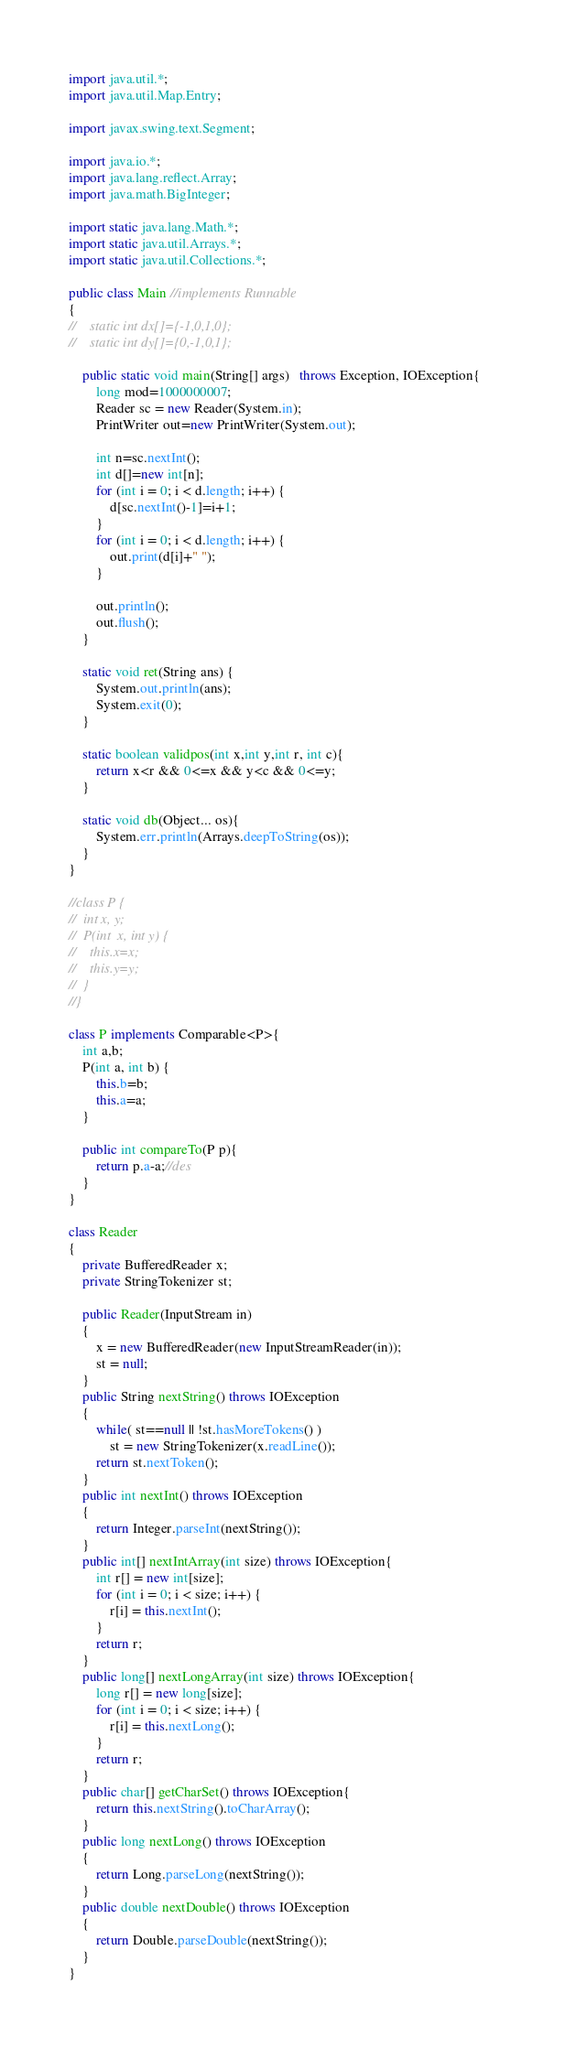Convert code to text. <code><loc_0><loc_0><loc_500><loc_500><_Java_>import java.util.*;
import java.util.Map.Entry;

import javax.swing.text.Segment;

import java.io.*;
import java.lang.reflect.Array;
import java.math.BigInteger;

import static java.lang.Math.*;
import static java.util.Arrays.*;
import static java.util.Collections.*;
 
public class Main //implements Runnable
{
//    static int dx[]={-1,0,1,0};
//    static int dy[]={0,-1,0,1};

    public static void main(String[] args)   throws Exception, IOException{        
        long mod=1000000007;
        Reader sc = new Reader(System.in);
        PrintWriter out=new PrintWriter(System.out);

        int n=sc.nextInt();
        int d[]=new int[n];
        for (int i = 0; i < d.length; i++) {
			d[sc.nextInt()-1]=i+1;
		}
        for (int i = 0; i < d.length; i++) {
			out.print(d[i]+" ");
		}
        
        out.println();
     	out.flush();
    }
    
    static void ret(String ans) {
    	System.out.println(ans);
    	System.exit(0);
    }
    
    static boolean validpos(int x,int y,int r, int c){
        return x<r && 0<=x && y<c && 0<=y;
    }

    static void db(Object... os){
        System.err.println(Arrays.deepToString(os));
    }
}

//class P {
//	int x, y;
//	P(int  x, int y) {
//	  this.x=x;
//	  this.y=y;
//	}
//}

class P implements Comparable<P>{
    int a,b;
    P(int a, int b) {
    	this.b=b;
    	this.a=a;
    }

    public int compareTo(P p){
        return p.a-a;//des
    }
}

class Reader
{ 
    private BufferedReader x;
    private StringTokenizer st;
    
    public Reader(InputStream in)
    {
        x = new BufferedReader(new InputStreamReader(in));
        st = null;
    }
    public String nextString() throws IOException
    {
        while( st==null || !st.hasMoreTokens() )
            st = new StringTokenizer(x.readLine());
        return st.nextToken();
    }
    public int nextInt() throws IOException
    {
        return Integer.parseInt(nextString());
    }
    public int[] nextIntArray(int size) throws IOException{
        int r[] = new int[size];
        for (int i = 0; i < size; i++) {
            r[i] = this.nextInt(); 
        }
        return r;
    }
    public long[] nextLongArray(int size) throws IOException{
        long r[] = new long[size];
        for (int i = 0; i < size; i++) {
            r[i] = this.nextLong(); 
        }
        return r;
    }
    public char[] getCharSet() throws IOException{
        return this.nextString().toCharArray();
    }    
    public long nextLong() throws IOException
    {
        return Long.parseLong(nextString());
    }
    public double nextDouble() throws IOException
    {
        return Double.parseDouble(nextString());
    }
}
</code> 